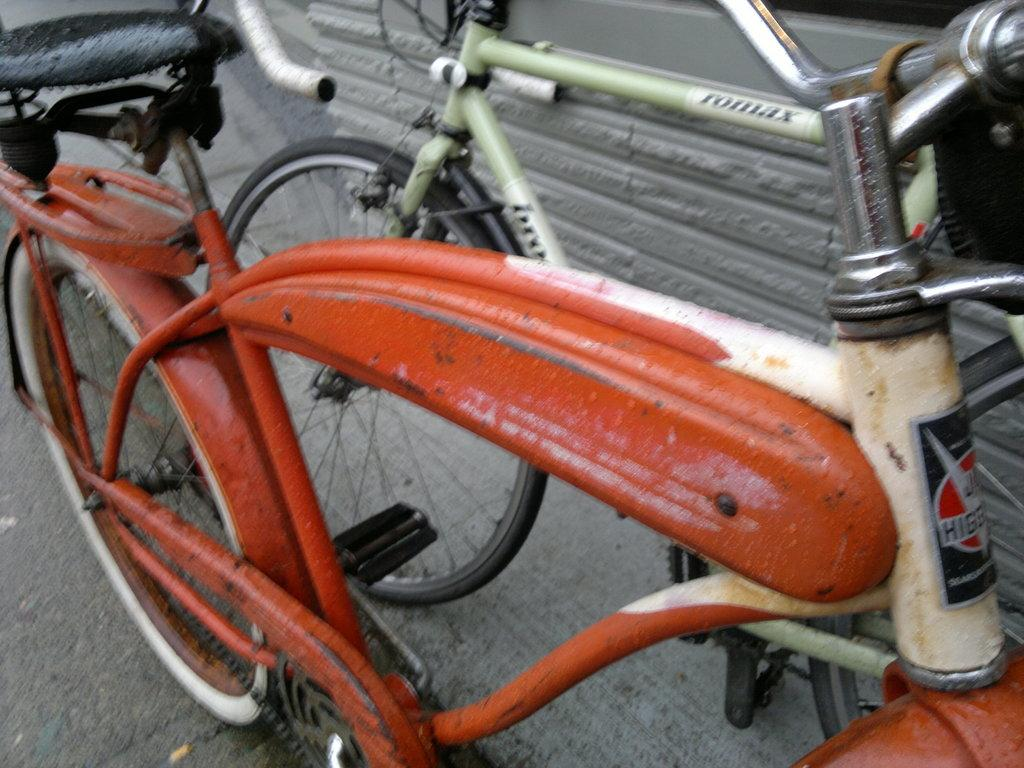How many bicycles are in the image? There are two bicycles in the image. What colors are the bicycles? One bicycle is orange, and the other bicycle is green. What direction is the dime pointing on the green bicycle in the image? There is no dime present on either bicycle in the image. 